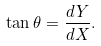<formula> <loc_0><loc_0><loc_500><loc_500>\tan \theta = \frac { d Y } { d X } .</formula> 